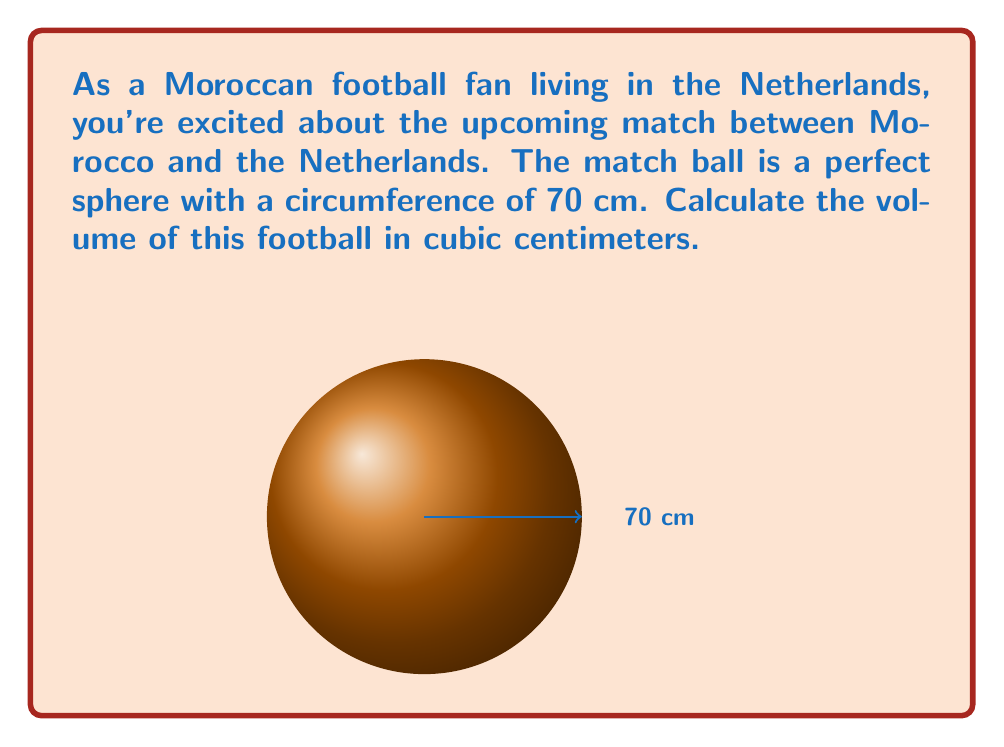Show me your answer to this math problem. Let's approach this step-by-step:

1) First, we need to find the radius of the football. We know the circumference is 70 cm.
   The formula for circumference is: $C = 2\pi r$
   where $C$ is circumference and $r$ is radius.

2) Rearranging the formula to solve for $r$:
   $r = \frac{C}{2\pi}$

3) Substituting the known values:
   $r = \frac{70}{2\pi} \approx 11.14$ cm

4) Now that we have the radius, we can use the formula for the volume of a sphere:
   $V = \frac{4}{3}\pi r^3$

5) Substituting our calculated radius:
   $V = \frac{4}{3}\pi (11.14)^3$

6) Calculating:
   $V \approx 5778.69$ cm³

Therefore, the volume of the football is approximately 5778.69 cubic centimeters.
Answer: $$5778.69 \text{ cm}^3$$ 